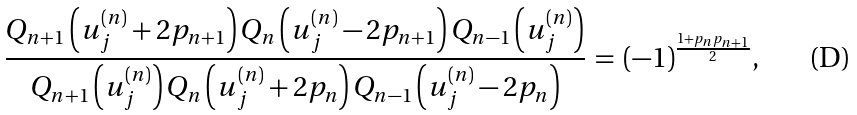Convert formula to latex. <formula><loc_0><loc_0><loc_500><loc_500>\frac { Q _ { n + 1 } \left ( u _ { j } ^ { ( n ) } + 2 p _ { n + 1 } \right ) Q _ { n } \left ( u _ { j } ^ { ( n ) } - 2 p _ { n + 1 } \right ) Q _ { n - 1 } \left ( u _ { j } ^ { ( n ) } \right ) } { Q _ { n + 1 } \left ( u _ { j } ^ { ( n ) } \right ) Q _ { n } \left ( u _ { j } ^ { ( n ) } + 2 p _ { n } \right ) Q _ { n - 1 } \left ( u _ { j } ^ { ( n ) } - 2 p _ { n } \right ) } \, = \, ( - 1 ) ^ { \frac { 1 + p _ { n } p _ { n + 1 } } { 2 } } ,</formula> 